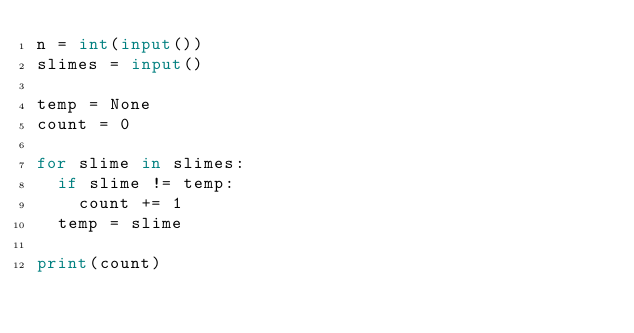Convert code to text. <code><loc_0><loc_0><loc_500><loc_500><_Python_>n = int(input())
slimes = input()

temp = None
count = 0

for slime in slimes:
  if slime != temp:
    count += 1
  temp = slime

print(count)</code> 